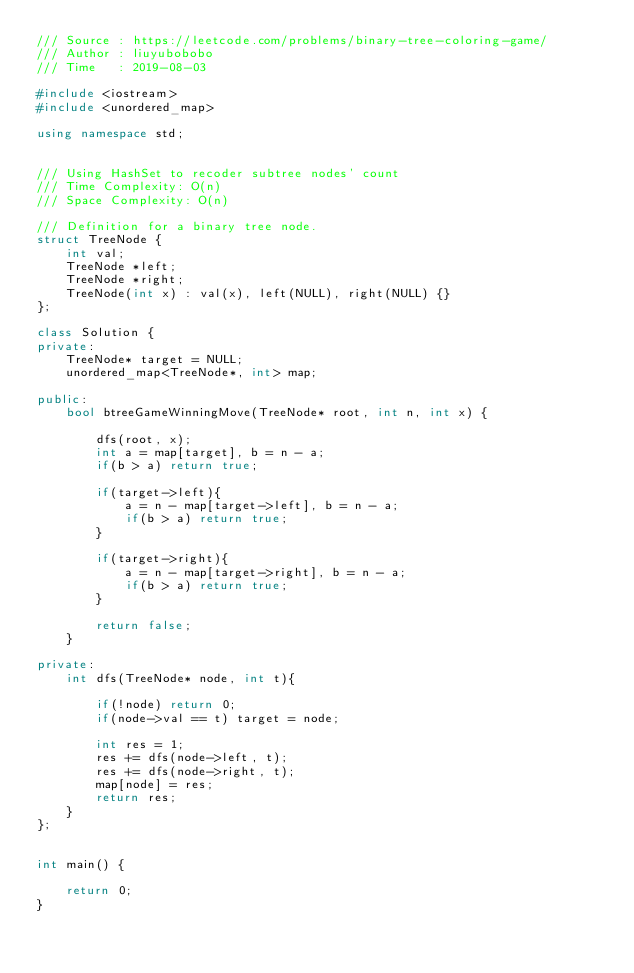Convert code to text. <code><loc_0><loc_0><loc_500><loc_500><_C++_>/// Source : https://leetcode.com/problems/binary-tree-coloring-game/
/// Author : liuyubobobo
/// Time   : 2019-08-03

#include <iostream>
#include <unordered_map>

using namespace std;


/// Using HashSet to recoder subtree nodes' count
/// Time Complexity: O(n)
/// Space Complexity: O(n)

/// Definition for a binary tree node.
struct TreeNode {
    int val;
    TreeNode *left;
    TreeNode *right;
    TreeNode(int x) : val(x), left(NULL), right(NULL) {}
};

class Solution {
private:
    TreeNode* target = NULL;
    unordered_map<TreeNode*, int> map;

public:
    bool btreeGameWinningMove(TreeNode* root, int n, int x) {

        dfs(root, x);
        int a = map[target], b = n - a;
        if(b > a) return true;

        if(target->left){
            a = n - map[target->left], b = n - a;
            if(b > a) return true;
        }

        if(target->right){
            a = n - map[target->right], b = n - a;
            if(b > a) return true;
        }

        return false;
    }

private:
    int dfs(TreeNode* node, int t){

        if(!node) return 0;
        if(node->val == t) target = node;

        int res = 1;
        res += dfs(node->left, t);
        res += dfs(node->right, t);
        map[node] = res;
        return res;
    }
};


int main() {

    return 0;
}</code> 